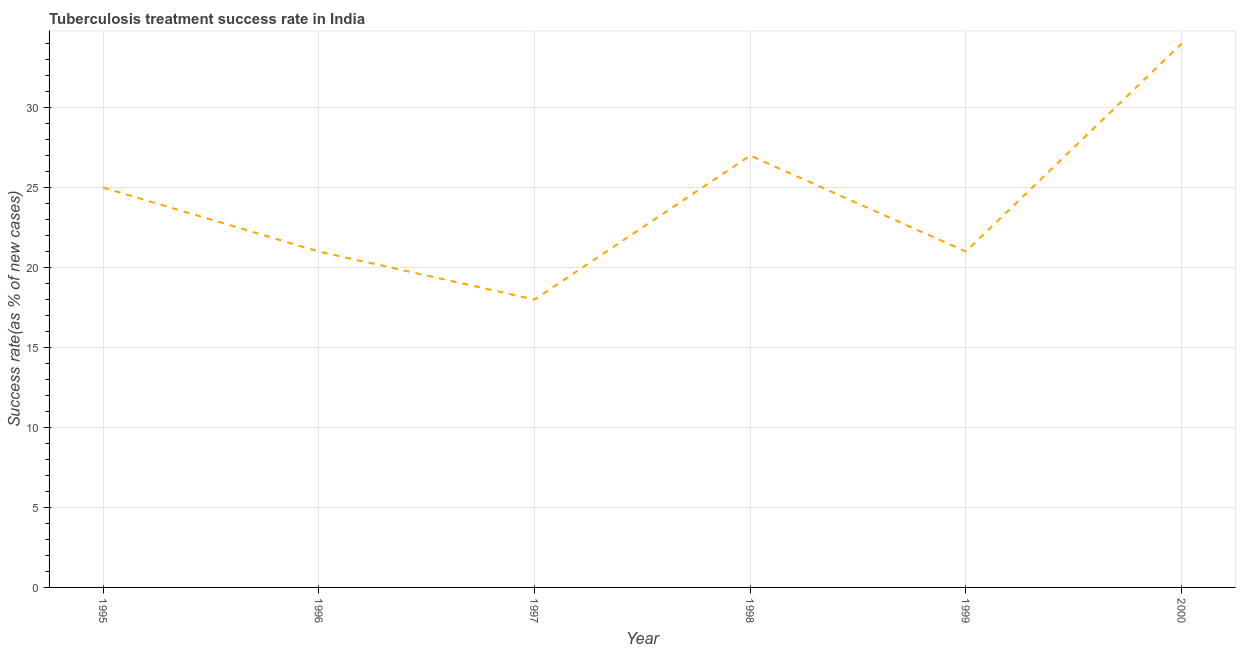What is the tuberculosis treatment success rate in 1995?
Provide a succinct answer. 25. Across all years, what is the maximum tuberculosis treatment success rate?
Give a very brief answer. 34. Across all years, what is the minimum tuberculosis treatment success rate?
Offer a very short reply. 18. In which year was the tuberculosis treatment success rate maximum?
Offer a very short reply. 2000. In which year was the tuberculosis treatment success rate minimum?
Keep it short and to the point. 1997. What is the sum of the tuberculosis treatment success rate?
Your answer should be very brief. 146. What is the difference between the tuberculosis treatment success rate in 1997 and 1998?
Keep it short and to the point. -9. What is the average tuberculosis treatment success rate per year?
Give a very brief answer. 24.33. Do a majority of the years between 1998 and 1997 (inclusive) have tuberculosis treatment success rate greater than 23 %?
Keep it short and to the point. No. What is the ratio of the tuberculosis treatment success rate in 1995 to that in 1996?
Provide a succinct answer. 1.19. Is the tuberculosis treatment success rate in 1996 less than that in 1997?
Keep it short and to the point. No. Is the difference between the tuberculosis treatment success rate in 1995 and 1997 greater than the difference between any two years?
Ensure brevity in your answer.  No. What is the difference between the highest and the lowest tuberculosis treatment success rate?
Ensure brevity in your answer.  16. In how many years, is the tuberculosis treatment success rate greater than the average tuberculosis treatment success rate taken over all years?
Your answer should be very brief. 3. How many lines are there?
Provide a succinct answer. 1. How many years are there in the graph?
Provide a short and direct response. 6. What is the difference between two consecutive major ticks on the Y-axis?
Ensure brevity in your answer.  5. Does the graph contain any zero values?
Ensure brevity in your answer.  No. Does the graph contain grids?
Provide a short and direct response. Yes. What is the title of the graph?
Provide a short and direct response. Tuberculosis treatment success rate in India. What is the label or title of the Y-axis?
Offer a terse response. Success rate(as % of new cases). What is the Success rate(as % of new cases) of 1996?
Provide a succinct answer. 21. What is the Success rate(as % of new cases) in 1997?
Provide a succinct answer. 18. What is the Success rate(as % of new cases) of 2000?
Offer a terse response. 34. What is the difference between the Success rate(as % of new cases) in 1995 and 1996?
Offer a very short reply. 4. What is the difference between the Success rate(as % of new cases) in 1995 and 1997?
Give a very brief answer. 7. What is the difference between the Success rate(as % of new cases) in 1995 and 1998?
Your response must be concise. -2. What is the difference between the Success rate(as % of new cases) in 1995 and 2000?
Make the answer very short. -9. What is the difference between the Success rate(as % of new cases) in 1996 and 1997?
Keep it short and to the point. 3. What is the difference between the Success rate(as % of new cases) in 1996 and 1998?
Offer a very short reply. -6. What is the difference between the Success rate(as % of new cases) in 1996 and 2000?
Your answer should be very brief. -13. What is the difference between the Success rate(as % of new cases) in 1997 and 1998?
Offer a very short reply. -9. What is the difference between the Success rate(as % of new cases) in 1997 and 1999?
Your answer should be compact. -3. What is the difference between the Success rate(as % of new cases) in 1997 and 2000?
Ensure brevity in your answer.  -16. What is the difference between the Success rate(as % of new cases) in 1998 and 1999?
Make the answer very short. 6. What is the difference between the Success rate(as % of new cases) in 1998 and 2000?
Your response must be concise. -7. What is the ratio of the Success rate(as % of new cases) in 1995 to that in 1996?
Provide a short and direct response. 1.19. What is the ratio of the Success rate(as % of new cases) in 1995 to that in 1997?
Provide a short and direct response. 1.39. What is the ratio of the Success rate(as % of new cases) in 1995 to that in 1998?
Provide a short and direct response. 0.93. What is the ratio of the Success rate(as % of new cases) in 1995 to that in 1999?
Your answer should be very brief. 1.19. What is the ratio of the Success rate(as % of new cases) in 1995 to that in 2000?
Offer a terse response. 0.73. What is the ratio of the Success rate(as % of new cases) in 1996 to that in 1997?
Keep it short and to the point. 1.17. What is the ratio of the Success rate(as % of new cases) in 1996 to that in 1998?
Offer a terse response. 0.78. What is the ratio of the Success rate(as % of new cases) in 1996 to that in 1999?
Your response must be concise. 1. What is the ratio of the Success rate(as % of new cases) in 1996 to that in 2000?
Offer a terse response. 0.62. What is the ratio of the Success rate(as % of new cases) in 1997 to that in 1998?
Offer a terse response. 0.67. What is the ratio of the Success rate(as % of new cases) in 1997 to that in 1999?
Keep it short and to the point. 0.86. What is the ratio of the Success rate(as % of new cases) in 1997 to that in 2000?
Give a very brief answer. 0.53. What is the ratio of the Success rate(as % of new cases) in 1998 to that in 1999?
Ensure brevity in your answer.  1.29. What is the ratio of the Success rate(as % of new cases) in 1998 to that in 2000?
Ensure brevity in your answer.  0.79. What is the ratio of the Success rate(as % of new cases) in 1999 to that in 2000?
Offer a terse response. 0.62. 